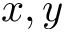Convert formula to latex. <formula><loc_0><loc_0><loc_500><loc_500>x , y</formula> 